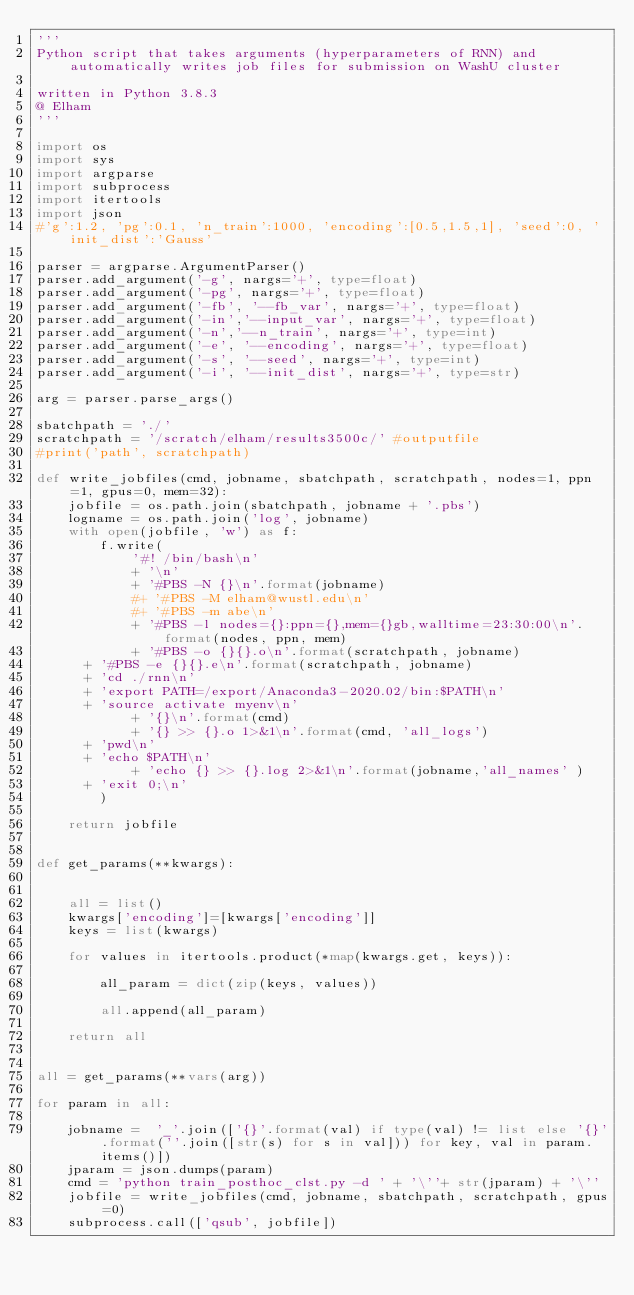Convert code to text. <code><loc_0><loc_0><loc_500><loc_500><_Python_>'''
Python script that takes arguments (hyperparameters of RNN) and automatically writes job files for submission on WashU cluster

written in Python 3.8.3
@ Elham
'''

import os
import sys
import argparse
import subprocess
import itertools
import json
#'g':1.2, 'pg':0.1, 'n_train':1000, 'encoding':[0.5,1.5,1], 'seed':0, 'init_dist':'Gauss'

parser = argparse.ArgumentParser()
parser.add_argument('-g', nargs='+', type=float)
parser.add_argument('-pg', nargs='+', type=float)
parser.add_argument('-fb', '--fb_var', nargs='+', type=float)
parser.add_argument('-in','--input_var', nargs='+', type=float)
parser.add_argument('-n','--n_train', nargs='+', type=int)
parser.add_argument('-e', '--encoding', nargs='+', type=float)
parser.add_argument('-s', '--seed', nargs='+', type=int)
parser.add_argument('-i', '--init_dist', nargs='+', type=str)

arg = parser.parse_args()

sbatchpath = './'
scratchpath = '/scratch/elham/results3500c/' #outputfile
#print('path', scratchpath)

def write_jobfiles(cmd, jobname, sbatchpath, scratchpath, nodes=1, ppn=1, gpus=0, mem=32):
    jobfile = os.path.join(sbatchpath, jobname + '.pbs')
    logname = os.path.join('log', jobname)
    with open(jobfile, 'w') as f:
        f.write(
            '#! /bin/bash\n'
            + '\n'
            + '#PBS -N {}\n'.format(jobname)
            #+ '#PBS -M elham@wustl.edu\n'
            #+ '#PBS -m abe\n'
            + '#PBS -l nodes={}:ppn={},mem={}gb,walltime=23:30:00\n'.format(nodes, ppn, mem)
            + '#PBS -o {}{}.o\n'.format(scratchpath, jobname)
	    + '#PBS -e {}{}.e\n'.format(scratchpath, jobname)
	    + 'cd ./rnn\n'
	    + 'export PATH=/export/Anaconda3-2020.02/bin:$PATH\n'
	    + 'source activate myenv\n'
            + '{}\n'.format(cmd)
            + '{} >> {}.o 1>&1\n'.format(cmd, 'all_logs')
	    + 'pwd\n'
	    + 'echo $PATH\n'
            + 'echo {} >> {}.log 2>&1\n'.format(jobname,'all_names' )
	    + 'exit 0;\n'
        )

    return jobfile


def get_params(**kwargs):
   

    all = list()
    kwargs['encoding']=[kwargs['encoding']]
    keys = list(kwargs)
    
    for values in itertools.product(*map(kwargs.get, keys)):
       
        all_param = dict(zip(keys, values))

        all.append(all_param)

    return all


all = get_params(**vars(arg))

for param in all:
   
    jobname =  '_'.join(['{}'.format(val) if type(val) != list else '{}'.format(''.join([str(s) for s in val])) for key, val in param.items()])
    jparam = json.dumps(param)
    cmd = 'python train_posthoc_clst.py -d ' + '\''+ str(jparam) + '\''
    jobfile = write_jobfiles(cmd, jobname, sbatchpath, scratchpath, gpus=0)
    subprocess.call(['qsub', jobfile])













</code> 